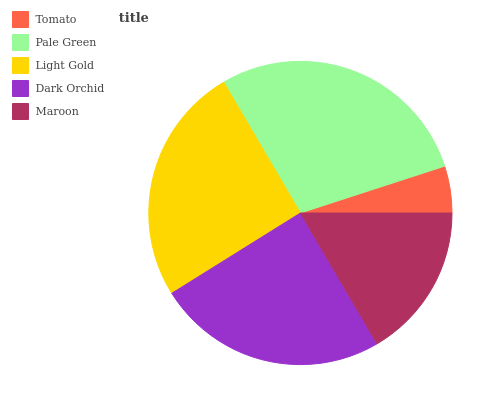Is Tomato the minimum?
Answer yes or no. Yes. Is Pale Green the maximum?
Answer yes or no. Yes. Is Light Gold the minimum?
Answer yes or no. No. Is Light Gold the maximum?
Answer yes or no. No. Is Pale Green greater than Light Gold?
Answer yes or no. Yes. Is Light Gold less than Pale Green?
Answer yes or no. Yes. Is Light Gold greater than Pale Green?
Answer yes or no. No. Is Pale Green less than Light Gold?
Answer yes or no. No. Is Dark Orchid the high median?
Answer yes or no. Yes. Is Dark Orchid the low median?
Answer yes or no. Yes. Is Tomato the high median?
Answer yes or no. No. Is Light Gold the low median?
Answer yes or no. No. 